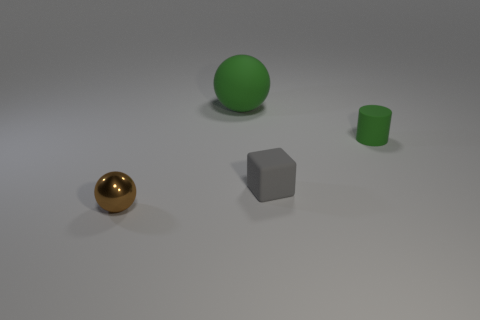What size is the thing that is the same color as the cylinder?
Offer a terse response. Large. Are there any other things that are made of the same material as the small sphere?
Provide a succinct answer. No. Does the large green matte object have the same shape as the tiny matte object on the left side of the small green rubber object?
Your answer should be very brief. No. Is there a big brown thing that has the same shape as the small brown metal thing?
Your response must be concise. No. There is a thing that is to the left of the sphere that is behind the tiny green cylinder; what is its shape?
Provide a short and direct response. Sphere. What shape is the green rubber object that is on the right side of the large green object?
Give a very brief answer. Cylinder. There is a small object behind the gray cube; is its color the same as the matte object that is on the left side of the small gray block?
Your response must be concise. Yes. How many balls are both in front of the big green ball and on the right side of the small metallic object?
Provide a short and direct response. 0. There is a cylinder that is the same material as the gray object; what size is it?
Ensure brevity in your answer.  Small. The metallic thing is what size?
Offer a terse response. Small. 